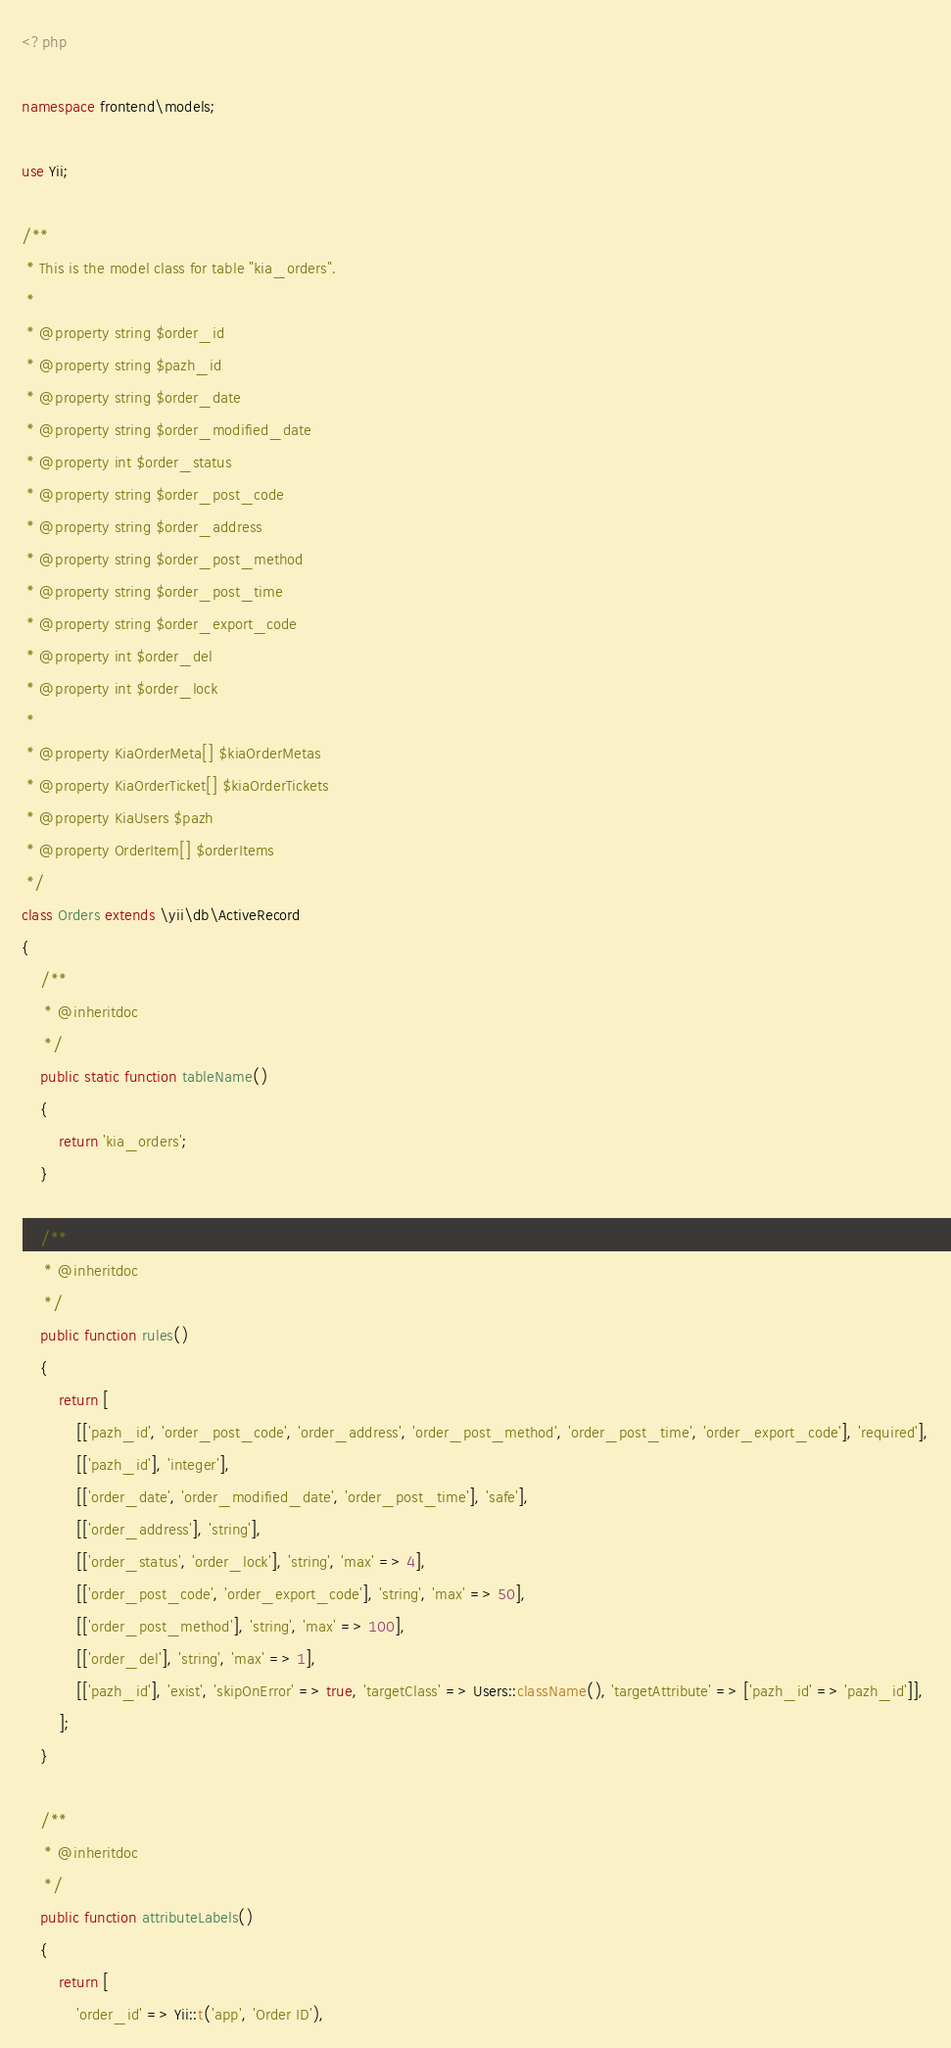Convert code to text. <code><loc_0><loc_0><loc_500><loc_500><_PHP_><?php

namespace frontend\models;

use Yii;

/**
 * This is the model class for table "kia_orders".
 *
 * @property string $order_id
 * @property string $pazh_id
 * @property string $order_date
 * @property string $order_modified_date
 * @property int $order_status
 * @property string $order_post_code
 * @property string $order_address
 * @property string $order_post_method
 * @property string $order_post_time
 * @property string $order_export_code
 * @property int $order_del
 * @property int $order_lock
 *
 * @property KiaOrderMeta[] $kiaOrderMetas
 * @property KiaOrderTicket[] $kiaOrderTickets
 * @property KiaUsers $pazh
 * @property OrderItem[] $orderItems
 */
class Orders extends \yii\db\ActiveRecord
{
    /**
     * @inheritdoc
     */
    public static function tableName()
    {
        return 'kia_orders';
    }

    /**
     * @inheritdoc
     */
    public function rules()
    {
        return [
            [['pazh_id', 'order_post_code', 'order_address', 'order_post_method', 'order_post_time', 'order_export_code'], 'required'],
            [['pazh_id'], 'integer'],
            [['order_date', 'order_modified_date', 'order_post_time'], 'safe'],
            [['order_address'], 'string'],
            [['order_status', 'order_lock'], 'string', 'max' => 4],
            [['order_post_code', 'order_export_code'], 'string', 'max' => 50],
            [['order_post_method'], 'string', 'max' => 100],
            [['order_del'], 'string', 'max' => 1],
            [['pazh_id'], 'exist', 'skipOnError' => true, 'targetClass' => Users::className(), 'targetAttribute' => ['pazh_id' => 'pazh_id']],
        ];
    }

    /**
     * @inheritdoc
     */
    public function attributeLabels()
    {
        return [
            'order_id' => Yii::t('app', 'Order ID'),</code> 